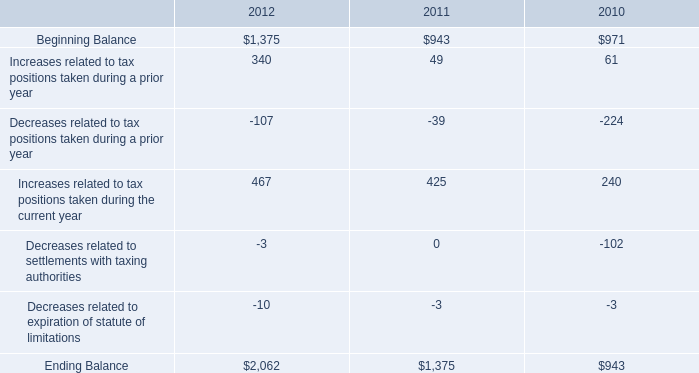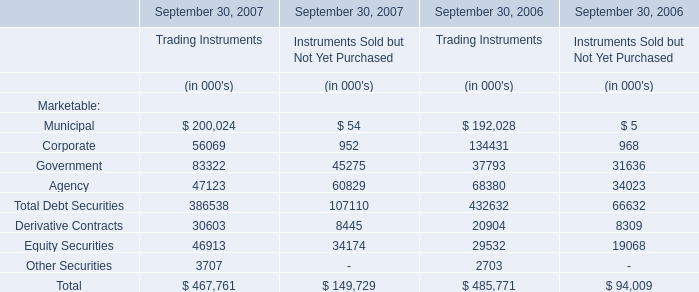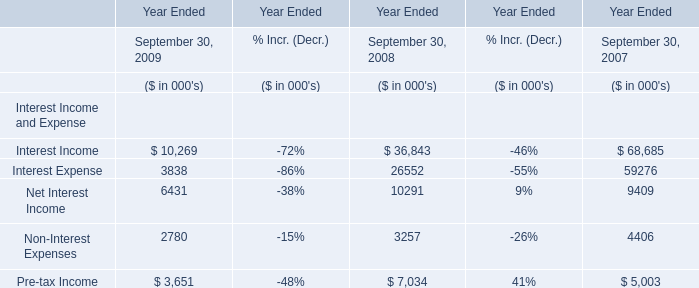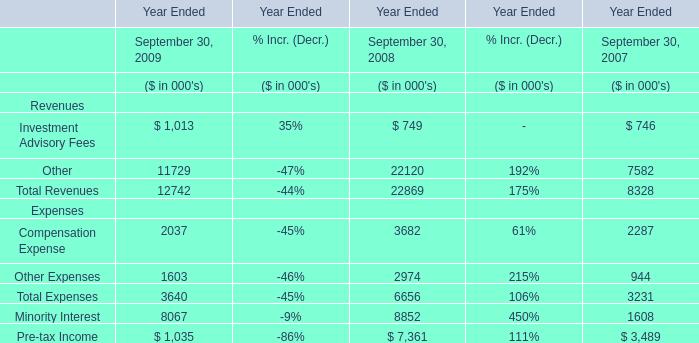What's the current growth rate of Other Expenses? (in %) 
Computations: ((1603 - 2974) / 2974)
Answer: -0.461. 